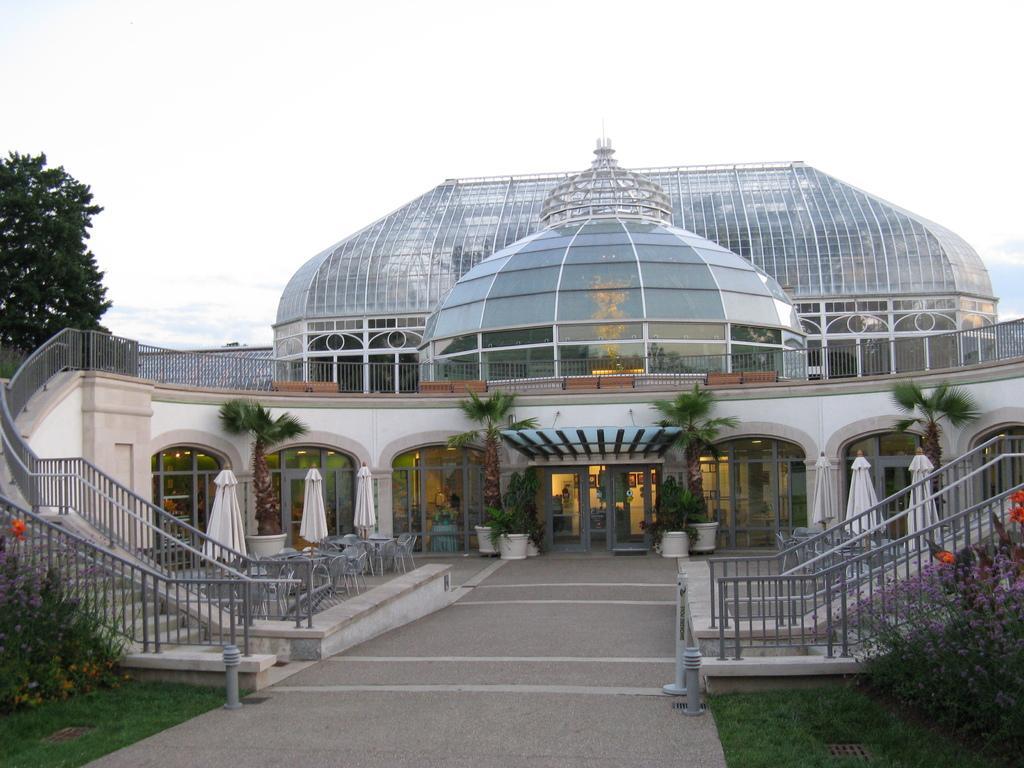Describe this image in one or two sentences. In the middle of the picture we can see trees, plants, chairs, tables, staircases and building. In the foreground there are plants, grass and path. On the left there is a tree. At the top it is sky. 